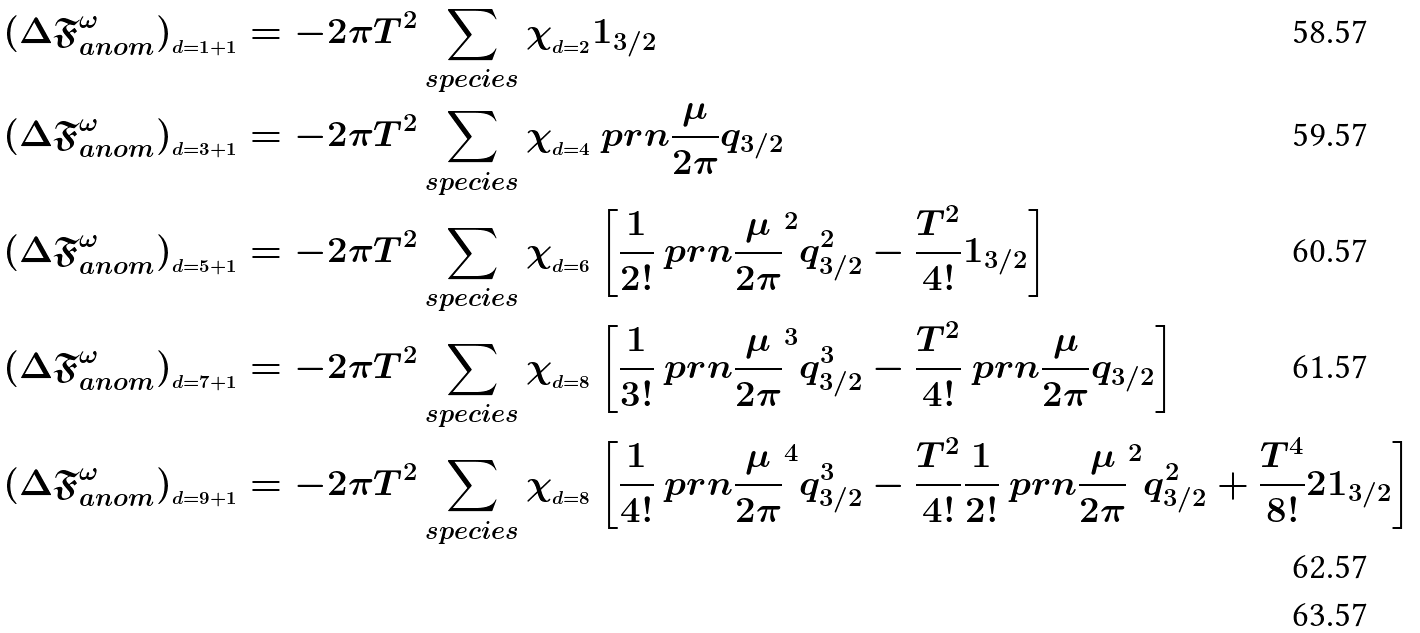<formula> <loc_0><loc_0><loc_500><loc_500>( \Delta \mathfrak { F } ^ { \omega } _ { a n o m } ) _ { _ { d = 1 + 1 } } & = - 2 \pi T ^ { 2 } \sum _ { s p e c i e s } \chi _ { _ { d = 2 } } 1 _ { 3 / 2 } \\ ( \Delta \mathfrak { F } ^ { \omega } _ { a n o m } ) _ { _ { d = 3 + 1 } } & = - 2 \pi T ^ { 2 } \sum _ { s p e c i e s } \chi _ { _ { d = 4 } } \ p r n { \frac { \mu } { 2 \pi } } q _ { 3 / 2 } \\ ( \Delta \mathfrak { F } ^ { \omega } _ { a n o m } ) _ { _ { d = 5 + 1 } } & = - 2 \pi T ^ { 2 } \sum _ { s p e c i e s } \chi _ { _ { d = 6 } } \left [ \frac { 1 } { 2 ! } \ p r n { \frac { \mu } { 2 \pi } } ^ { 2 } q ^ { 2 } _ { 3 / 2 } - \frac { T ^ { 2 } } { 4 ! } 1 _ { 3 / 2 } \right ] \\ ( \Delta \mathfrak { F } ^ { \omega } _ { a n o m } ) _ { _ { d = 7 + 1 } } & = - 2 \pi T ^ { 2 } \sum _ { s p e c i e s } \chi _ { _ { d = 8 } } \left [ \frac { 1 } { 3 ! } \ p r n { \frac { \mu } { 2 \pi } } ^ { 3 } q ^ { 3 } _ { 3 / 2 } - \frac { T ^ { 2 } } { 4 ! } \ p r n { \frac { \mu } { 2 \pi } } q _ { 3 / 2 } \right ] \\ ( \Delta \mathfrak { F } ^ { \omega } _ { a n o m } ) _ { _ { d = 9 + 1 } } & = - 2 \pi T ^ { 2 } \sum _ { s p e c i e s } \chi _ { _ { d = 8 } } \left [ \frac { 1 } { 4 ! } \ p r n { \frac { \mu } { 2 \pi } } ^ { 4 } q ^ { 3 } _ { 3 / 2 } - \frac { T ^ { 2 } } { 4 ! } \frac { 1 } { 2 ! } \ p r n { \frac { \mu } { 2 \pi } } ^ { 2 } q ^ { 2 } _ { 3 / 2 } + \frac { T ^ { 4 } } { 8 ! } 2 1 _ { 3 / 2 } \right ] \\</formula> 